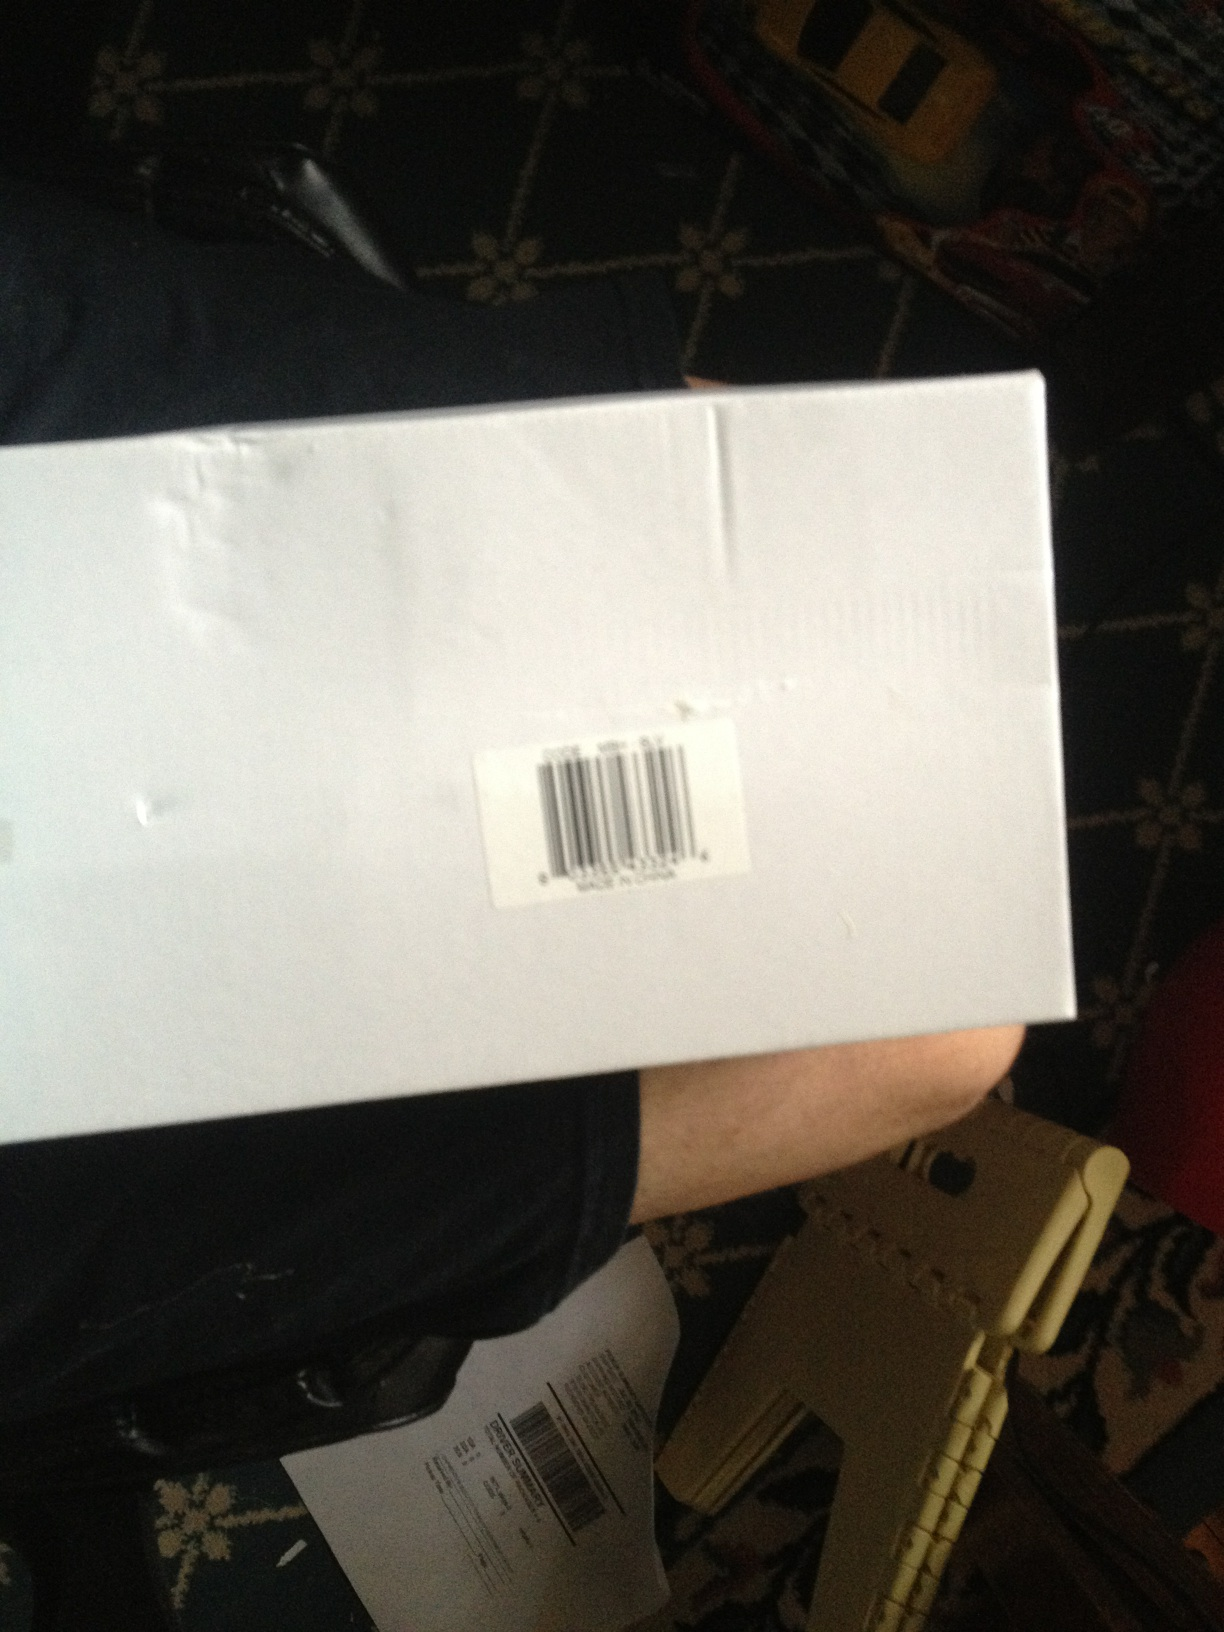What do you think this box was used for? Given its appearance, the box was likely used for shipping or storing a product. The barcode label suggests it was part of an inventory or logistics process. Can you look inside the box without opening it? While I can't physically open the box, let's imagine peeking inside! Visualize lifting the lid to reveal a neatly packed designer watch cushioned with protective foam, highlighting the attention to detail and care taken in packaging. 